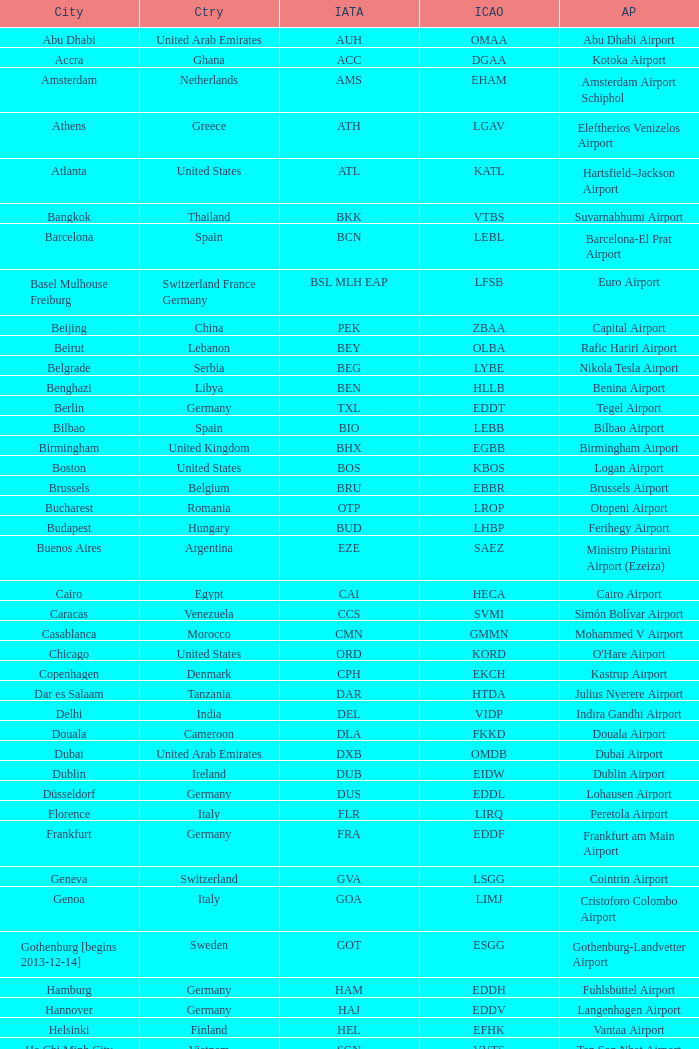What is the IATA for Ringway Airport in the United Kingdom? MAN. 